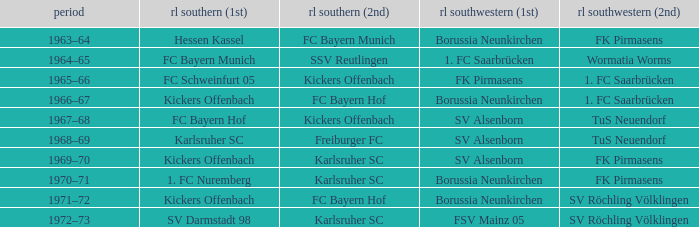What season did SV Darmstadt 98 end up at RL Süd (1st)? 1972–73. 